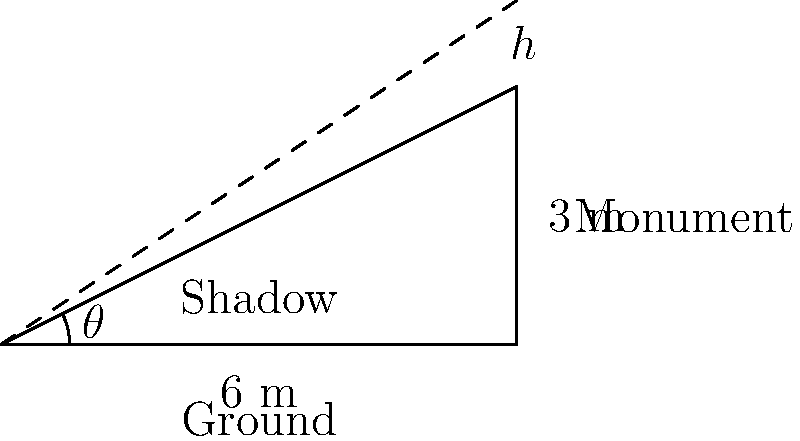During your visit to a famous local monument, your guide mentions that it's possible to calculate the height of the structure using its shadow. At noon, when the monument casts a shadow 6 meters long, the angle of elevation from the tip of the shadow to the top of the monument is measured to be $\theta$. If the shadow of your 1.8-meter tall local guide measures 3 meters at the same time, what is the height $h$ of the monument in meters? Let's approach this step-by-step:

1) First, we can find the angle $\theta$ using the guide's height and shadow length:
   $\tan \theta = \frac{1.8}{3} = 0.6$
   $\theta = \arctan(0.6) \approx 30.96°$

2) Now that we know the angle, we can use it to find the height of the monument:
   $\tan \theta = \frac{h}{6}$, where $h$ is the height of the monument

3) Substituting the value of $\tan \theta$ we found earlier:
   $0.6 = \frac{h}{6}$

4) Solving for $h$:
   $h = 6 \times 0.6 = 3.6$

Therefore, the height of the monument is 3.6 meters.
Answer: $3.6$ m 